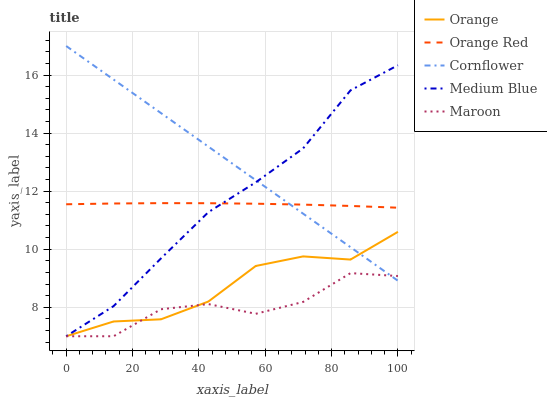Does Medium Blue have the minimum area under the curve?
Answer yes or no. No. Does Medium Blue have the maximum area under the curve?
Answer yes or no. No. Is Medium Blue the smoothest?
Answer yes or no. No. Is Medium Blue the roughest?
Answer yes or no. No. Does Cornflower have the lowest value?
Answer yes or no. No. Does Medium Blue have the highest value?
Answer yes or no. No. Is Orange less than Orange Red?
Answer yes or no. Yes. Is Orange Red greater than Maroon?
Answer yes or no. Yes. Does Orange intersect Orange Red?
Answer yes or no. No. 